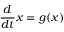<formula> <loc_0><loc_0><loc_500><loc_500>\frac { d } { d t } x = g ( x )</formula> 